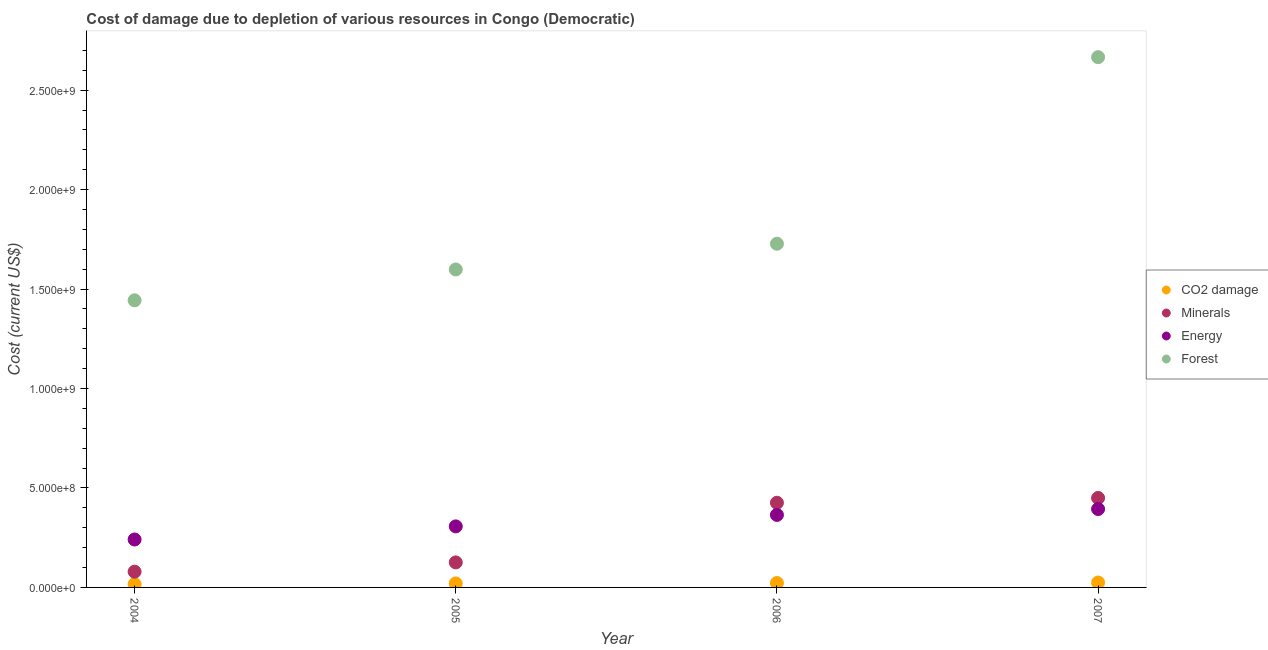Is the number of dotlines equal to the number of legend labels?
Ensure brevity in your answer.  Yes. What is the cost of damage due to depletion of forests in 2006?
Provide a short and direct response. 1.73e+09. Across all years, what is the maximum cost of damage due to depletion of energy?
Ensure brevity in your answer.  3.94e+08. Across all years, what is the minimum cost of damage due to depletion of minerals?
Offer a terse response. 7.91e+07. In which year was the cost of damage due to depletion of forests maximum?
Give a very brief answer. 2007. In which year was the cost of damage due to depletion of minerals minimum?
Give a very brief answer. 2004. What is the total cost of damage due to depletion of energy in the graph?
Offer a terse response. 1.31e+09. What is the difference between the cost of damage due to depletion of energy in 2004 and that in 2005?
Offer a terse response. -6.59e+07. What is the difference between the cost of damage due to depletion of energy in 2006 and the cost of damage due to depletion of minerals in 2004?
Provide a short and direct response. 2.85e+08. What is the average cost of damage due to depletion of coal per year?
Keep it short and to the point. 2.10e+07. In the year 2005, what is the difference between the cost of damage due to depletion of energy and cost of damage due to depletion of coal?
Ensure brevity in your answer.  2.87e+08. What is the ratio of the cost of damage due to depletion of coal in 2005 to that in 2006?
Provide a short and direct response. 0.9. Is the cost of damage due to depletion of coal in 2005 less than that in 2007?
Make the answer very short. Yes. What is the difference between the highest and the second highest cost of damage due to depletion of minerals?
Provide a short and direct response. 2.41e+07. What is the difference between the highest and the lowest cost of damage due to depletion of energy?
Provide a succinct answer. 1.53e+08. In how many years, is the cost of damage due to depletion of minerals greater than the average cost of damage due to depletion of minerals taken over all years?
Make the answer very short. 2. Is it the case that in every year, the sum of the cost of damage due to depletion of coal and cost of damage due to depletion of minerals is greater than the cost of damage due to depletion of energy?
Offer a terse response. No. Is the cost of damage due to depletion of forests strictly less than the cost of damage due to depletion of energy over the years?
Keep it short and to the point. No. How many dotlines are there?
Make the answer very short. 4. How many years are there in the graph?
Make the answer very short. 4. What is the difference between two consecutive major ticks on the Y-axis?
Your answer should be compact. 5.00e+08. Does the graph contain grids?
Offer a terse response. No. Where does the legend appear in the graph?
Keep it short and to the point. Center right. How many legend labels are there?
Your response must be concise. 4. What is the title of the graph?
Keep it short and to the point. Cost of damage due to depletion of various resources in Congo (Democratic) . What is the label or title of the X-axis?
Offer a terse response. Year. What is the label or title of the Y-axis?
Make the answer very short. Cost (current US$). What is the Cost (current US$) in CO2 damage in 2004?
Your answer should be very brief. 1.66e+07. What is the Cost (current US$) in Minerals in 2004?
Keep it short and to the point. 7.91e+07. What is the Cost (current US$) of Energy in 2004?
Your response must be concise. 2.41e+08. What is the Cost (current US$) in Forest in 2004?
Your answer should be very brief. 1.44e+09. What is the Cost (current US$) in CO2 damage in 2005?
Make the answer very short. 2.02e+07. What is the Cost (current US$) of Minerals in 2005?
Offer a very short reply. 1.26e+08. What is the Cost (current US$) of Energy in 2005?
Offer a very short reply. 3.07e+08. What is the Cost (current US$) in Forest in 2005?
Your answer should be very brief. 1.60e+09. What is the Cost (current US$) in CO2 damage in 2006?
Provide a short and direct response. 2.23e+07. What is the Cost (current US$) of Minerals in 2006?
Offer a very short reply. 4.26e+08. What is the Cost (current US$) in Energy in 2006?
Make the answer very short. 3.65e+08. What is the Cost (current US$) of Forest in 2006?
Offer a very short reply. 1.73e+09. What is the Cost (current US$) in CO2 damage in 2007?
Your answer should be very brief. 2.48e+07. What is the Cost (current US$) of Minerals in 2007?
Keep it short and to the point. 4.50e+08. What is the Cost (current US$) of Energy in 2007?
Provide a succinct answer. 3.94e+08. What is the Cost (current US$) of Forest in 2007?
Your response must be concise. 2.67e+09. Across all years, what is the maximum Cost (current US$) in CO2 damage?
Offer a terse response. 2.48e+07. Across all years, what is the maximum Cost (current US$) in Minerals?
Provide a short and direct response. 4.50e+08. Across all years, what is the maximum Cost (current US$) of Energy?
Ensure brevity in your answer.  3.94e+08. Across all years, what is the maximum Cost (current US$) in Forest?
Your response must be concise. 2.67e+09. Across all years, what is the minimum Cost (current US$) of CO2 damage?
Keep it short and to the point. 1.66e+07. Across all years, what is the minimum Cost (current US$) in Minerals?
Ensure brevity in your answer.  7.91e+07. Across all years, what is the minimum Cost (current US$) in Energy?
Offer a very short reply. 2.41e+08. Across all years, what is the minimum Cost (current US$) of Forest?
Offer a terse response. 1.44e+09. What is the total Cost (current US$) in CO2 damage in the graph?
Ensure brevity in your answer.  8.38e+07. What is the total Cost (current US$) in Minerals in the graph?
Your answer should be compact. 1.08e+09. What is the total Cost (current US$) in Energy in the graph?
Your answer should be compact. 1.31e+09. What is the total Cost (current US$) of Forest in the graph?
Ensure brevity in your answer.  7.44e+09. What is the difference between the Cost (current US$) of CO2 damage in 2004 and that in 2005?
Your answer should be very brief. -3.55e+06. What is the difference between the Cost (current US$) of Minerals in 2004 and that in 2005?
Your response must be concise. -4.66e+07. What is the difference between the Cost (current US$) in Energy in 2004 and that in 2005?
Provide a short and direct response. -6.59e+07. What is the difference between the Cost (current US$) of Forest in 2004 and that in 2005?
Provide a short and direct response. -1.55e+08. What is the difference between the Cost (current US$) in CO2 damage in 2004 and that in 2006?
Your response must be concise. -5.69e+06. What is the difference between the Cost (current US$) of Minerals in 2004 and that in 2006?
Give a very brief answer. -3.46e+08. What is the difference between the Cost (current US$) in Energy in 2004 and that in 2006?
Keep it short and to the point. -1.24e+08. What is the difference between the Cost (current US$) of Forest in 2004 and that in 2006?
Keep it short and to the point. -2.84e+08. What is the difference between the Cost (current US$) in CO2 damage in 2004 and that in 2007?
Ensure brevity in your answer.  -8.19e+06. What is the difference between the Cost (current US$) of Minerals in 2004 and that in 2007?
Offer a very short reply. -3.71e+08. What is the difference between the Cost (current US$) in Energy in 2004 and that in 2007?
Ensure brevity in your answer.  -1.53e+08. What is the difference between the Cost (current US$) of Forest in 2004 and that in 2007?
Your answer should be very brief. -1.22e+09. What is the difference between the Cost (current US$) in CO2 damage in 2005 and that in 2006?
Ensure brevity in your answer.  -2.14e+06. What is the difference between the Cost (current US$) of Minerals in 2005 and that in 2006?
Ensure brevity in your answer.  -3.00e+08. What is the difference between the Cost (current US$) of Energy in 2005 and that in 2006?
Provide a succinct answer. -5.77e+07. What is the difference between the Cost (current US$) in Forest in 2005 and that in 2006?
Give a very brief answer. -1.29e+08. What is the difference between the Cost (current US$) of CO2 damage in 2005 and that in 2007?
Offer a very short reply. -4.64e+06. What is the difference between the Cost (current US$) of Minerals in 2005 and that in 2007?
Provide a short and direct response. -3.24e+08. What is the difference between the Cost (current US$) of Energy in 2005 and that in 2007?
Your answer should be compact. -8.72e+07. What is the difference between the Cost (current US$) of Forest in 2005 and that in 2007?
Your answer should be very brief. -1.07e+09. What is the difference between the Cost (current US$) of CO2 damage in 2006 and that in 2007?
Provide a succinct answer. -2.50e+06. What is the difference between the Cost (current US$) of Minerals in 2006 and that in 2007?
Ensure brevity in your answer.  -2.41e+07. What is the difference between the Cost (current US$) of Energy in 2006 and that in 2007?
Give a very brief answer. -2.96e+07. What is the difference between the Cost (current US$) in Forest in 2006 and that in 2007?
Provide a succinct answer. -9.38e+08. What is the difference between the Cost (current US$) of CO2 damage in 2004 and the Cost (current US$) of Minerals in 2005?
Provide a short and direct response. -1.09e+08. What is the difference between the Cost (current US$) of CO2 damage in 2004 and the Cost (current US$) of Energy in 2005?
Ensure brevity in your answer.  -2.90e+08. What is the difference between the Cost (current US$) in CO2 damage in 2004 and the Cost (current US$) in Forest in 2005?
Make the answer very short. -1.58e+09. What is the difference between the Cost (current US$) of Minerals in 2004 and the Cost (current US$) of Energy in 2005?
Offer a terse response. -2.28e+08. What is the difference between the Cost (current US$) of Minerals in 2004 and the Cost (current US$) of Forest in 2005?
Offer a terse response. -1.52e+09. What is the difference between the Cost (current US$) in Energy in 2004 and the Cost (current US$) in Forest in 2005?
Your response must be concise. -1.36e+09. What is the difference between the Cost (current US$) in CO2 damage in 2004 and the Cost (current US$) in Minerals in 2006?
Give a very brief answer. -4.09e+08. What is the difference between the Cost (current US$) of CO2 damage in 2004 and the Cost (current US$) of Energy in 2006?
Your response must be concise. -3.48e+08. What is the difference between the Cost (current US$) in CO2 damage in 2004 and the Cost (current US$) in Forest in 2006?
Your answer should be very brief. -1.71e+09. What is the difference between the Cost (current US$) of Minerals in 2004 and the Cost (current US$) of Energy in 2006?
Offer a very short reply. -2.85e+08. What is the difference between the Cost (current US$) in Minerals in 2004 and the Cost (current US$) in Forest in 2006?
Your answer should be compact. -1.65e+09. What is the difference between the Cost (current US$) in Energy in 2004 and the Cost (current US$) in Forest in 2006?
Provide a short and direct response. -1.49e+09. What is the difference between the Cost (current US$) in CO2 damage in 2004 and the Cost (current US$) in Minerals in 2007?
Keep it short and to the point. -4.33e+08. What is the difference between the Cost (current US$) of CO2 damage in 2004 and the Cost (current US$) of Energy in 2007?
Keep it short and to the point. -3.78e+08. What is the difference between the Cost (current US$) of CO2 damage in 2004 and the Cost (current US$) of Forest in 2007?
Ensure brevity in your answer.  -2.65e+09. What is the difference between the Cost (current US$) of Minerals in 2004 and the Cost (current US$) of Energy in 2007?
Give a very brief answer. -3.15e+08. What is the difference between the Cost (current US$) of Minerals in 2004 and the Cost (current US$) of Forest in 2007?
Make the answer very short. -2.59e+09. What is the difference between the Cost (current US$) of Energy in 2004 and the Cost (current US$) of Forest in 2007?
Provide a succinct answer. -2.42e+09. What is the difference between the Cost (current US$) of CO2 damage in 2005 and the Cost (current US$) of Minerals in 2006?
Provide a succinct answer. -4.05e+08. What is the difference between the Cost (current US$) of CO2 damage in 2005 and the Cost (current US$) of Energy in 2006?
Your answer should be very brief. -3.44e+08. What is the difference between the Cost (current US$) of CO2 damage in 2005 and the Cost (current US$) of Forest in 2006?
Your answer should be compact. -1.71e+09. What is the difference between the Cost (current US$) in Minerals in 2005 and the Cost (current US$) in Energy in 2006?
Provide a short and direct response. -2.39e+08. What is the difference between the Cost (current US$) in Minerals in 2005 and the Cost (current US$) in Forest in 2006?
Give a very brief answer. -1.60e+09. What is the difference between the Cost (current US$) of Energy in 2005 and the Cost (current US$) of Forest in 2006?
Give a very brief answer. -1.42e+09. What is the difference between the Cost (current US$) in CO2 damage in 2005 and the Cost (current US$) in Minerals in 2007?
Provide a succinct answer. -4.30e+08. What is the difference between the Cost (current US$) in CO2 damage in 2005 and the Cost (current US$) in Energy in 2007?
Offer a very short reply. -3.74e+08. What is the difference between the Cost (current US$) in CO2 damage in 2005 and the Cost (current US$) in Forest in 2007?
Offer a very short reply. -2.65e+09. What is the difference between the Cost (current US$) of Minerals in 2005 and the Cost (current US$) of Energy in 2007?
Offer a terse response. -2.68e+08. What is the difference between the Cost (current US$) in Minerals in 2005 and the Cost (current US$) in Forest in 2007?
Provide a succinct answer. -2.54e+09. What is the difference between the Cost (current US$) in Energy in 2005 and the Cost (current US$) in Forest in 2007?
Your answer should be compact. -2.36e+09. What is the difference between the Cost (current US$) of CO2 damage in 2006 and the Cost (current US$) of Minerals in 2007?
Ensure brevity in your answer.  -4.27e+08. What is the difference between the Cost (current US$) in CO2 damage in 2006 and the Cost (current US$) in Energy in 2007?
Your response must be concise. -3.72e+08. What is the difference between the Cost (current US$) in CO2 damage in 2006 and the Cost (current US$) in Forest in 2007?
Your answer should be compact. -2.64e+09. What is the difference between the Cost (current US$) of Minerals in 2006 and the Cost (current US$) of Energy in 2007?
Ensure brevity in your answer.  3.15e+07. What is the difference between the Cost (current US$) in Minerals in 2006 and the Cost (current US$) in Forest in 2007?
Make the answer very short. -2.24e+09. What is the difference between the Cost (current US$) in Energy in 2006 and the Cost (current US$) in Forest in 2007?
Ensure brevity in your answer.  -2.30e+09. What is the average Cost (current US$) in CO2 damage per year?
Offer a terse response. 2.10e+07. What is the average Cost (current US$) of Minerals per year?
Your answer should be very brief. 2.70e+08. What is the average Cost (current US$) of Energy per year?
Make the answer very short. 3.27e+08. What is the average Cost (current US$) in Forest per year?
Offer a terse response. 1.86e+09. In the year 2004, what is the difference between the Cost (current US$) of CO2 damage and Cost (current US$) of Minerals?
Give a very brief answer. -6.25e+07. In the year 2004, what is the difference between the Cost (current US$) in CO2 damage and Cost (current US$) in Energy?
Offer a terse response. -2.24e+08. In the year 2004, what is the difference between the Cost (current US$) of CO2 damage and Cost (current US$) of Forest?
Give a very brief answer. -1.43e+09. In the year 2004, what is the difference between the Cost (current US$) of Minerals and Cost (current US$) of Energy?
Your answer should be very brief. -1.62e+08. In the year 2004, what is the difference between the Cost (current US$) of Minerals and Cost (current US$) of Forest?
Give a very brief answer. -1.36e+09. In the year 2004, what is the difference between the Cost (current US$) in Energy and Cost (current US$) in Forest?
Ensure brevity in your answer.  -1.20e+09. In the year 2005, what is the difference between the Cost (current US$) in CO2 damage and Cost (current US$) in Minerals?
Your answer should be compact. -1.06e+08. In the year 2005, what is the difference between the Cost (current US$) in CO2 damage and Cost (current US$) in Energy?
Provide a short and direct response. -2.87e+08. In the year 2005, what is the difference between the Cost (current US$) of CO2 damage and Cost (current US$) of Forest?
Provide a short and direct response. -1.58e+09. In the year 2005, what is the difference between the Cost (current US$) in Minerals and Cost (current US$) in Energy?
Your response must be concise. -1.81e+08. In the year 2005, what is the difference between the Cost (current US$) of Minerals and Cost (current US$) of Forest?
Your response must be concise. -1.47e+09. In the year 2005, what is the difference between the Cost (current US$) in Energy and Cost (current US$) in Forest?
Keep it short and to the point. -1.29e+09. In the year 2006, what is the difference between the Cost (current US$) of CO2 damage and Cost (current US$) of Minerals?
Offer a very short reply. -4.03e+08. In the year 2006, what is the difference between the Cost (current US$) in CO2 damage and Cost (current US$) in Energy?
Your answer should be very brief. -3.42e+08. In the year 2006, what is the difference between the Cost (current US$) in CO2 damage and Cost (current US$) in Forest?
Offer a terse response. -1.71e+09. In the year 2006, what is the difference between the Cost (current US$) of Minerals and Cost (current US$) of Energy?
Keep it short and to the point. 6.11e+07. In the year 2006, what is the difference between the Cost (current US$) of Minerals and Cost (current US$) of Forest?
Your answer should be very brief. -1.30e+09. In the year 2006, what is the difference between the Cost (current US$) in Energy and Cost (current US$) in Forest?
Offer a very short reply. -1.36e+09. In the year 2007, what is the difference between the Cost (current US$) of CO2 damage and Cost (current US$) of Minerals?
Make the answer very short. -4.25e+08. In the year 2007, what is the difference between the Cost (current US$) in CO2 damage and Cost (current US$) in Energy?
Keep it short and to the point. -3.69e+08. In the year 2007, what is the difference between the Cost (current US$) of CO2 damage and Cost (current US$) of Forest?
Ensure brevity in your answer.  -2.64e+09. In the year 2007, what is the difference between the Cost (current US$) in Minerals and Cost (current US$) in Energy?
Keep it short and to the point. 5.56e+07. In the year 2007, what is the difference between the Cost (current US$) of Minerals and Cost (current US$) of Forest?
Your response must be concise. -2.22e+09. In the year 2007, what is the difference between the Cost (current US$) of Energy and Cost (current US$) of Forest?
Provide a succinct answer. -2.27e+09. What is the ratio of the Cost (current US$) in CO2 damage in 2004 to that in 2005?
Provide a succinct answer. 0.82. What is the ratio of the Cost (current US$) in Minerals in 2004 to that in 2005?
Make the answer very short. 0.63. What is the ratio of the Cost (current US$) of Energy in 2004 to that in 2005?
Offer a terse response. 0.79. What is the ratio of the Cost (current US$) in Forest in 2004 to that in 2005?
Your answer should be very brief. 0.9. What is the ratio of the Cost (current US$) in CO2 damage in 2004 to that in 2006?
Offer a very short reply. 0.74. What is the ratio of the Cost (current US$) in Minerals in 2004 to that in 2006?
Provide a succinct answer. 0.19. What is the ratio of the Cost (current US$) of Energy in 2004 to that in 2006?
Your answer should be very brief. 0.66. What is the ratio of the Cost (current US$) of Forest in 2004 to that in 2006?
Offer a very short reply. 0.84. What is the ratio of the Cost (current US$) in CO2 damage in 2004 to that in 2007?
Offer a terse response. 0.67. What is the ratio of the Cost (current US$) of Minerals in 2004 to that in 2007?
Keep it short and to the point. 0.18. What is the ratio of the Cost (current US$) in Energy in 2004 to that in 2007?
Provide a short and direct response. 0.61. What is the ratio of the Cost (current US$) in Forest in 2004 to that in 2007?
Your answer should be compact. 0.54. What is the ratio of the Cost (current US$) in CO2 damage in 2005 to that in 2006?
Provide a succinct answer. 0.9. What is the ratio of the Cost (current US$) of Minerals in 2005 to that in 2006?
Offer a terse response. 0.3. What is the ratio of the Cost (current US$) of Energy in 2005 to that in 2006?
Offer a very short reply. 0.84. What is the ratio of the Cost (current US$) in Forest in 2005 to that in 2006?
Make the answer very short. 0.93. What is the ratio of the Cost (current US$) in CO2 damage in 2005 to that in 2007?
Give a very brief answer. 0.81. What is the ratio of the Cost (current US$) of Minerals in 2005 to that in 2007?
Provide a short and direct response. 0.28. What is the ratio of the Cost (current US$) of Energy in 2005 to that in 2007?
Make the answer very short. 0.78. What is the ratio of the Cost (current US$) of Forest in 2005 to that in 2007?
Provide a short and direct response. 0.6. What is the ratio of the Cost (current US$) of CO2 damage in 2006 to that in 2007?
Provide a short and direct response. 0.9. What is the ratio of the Cost (current US$) of Minerals in 2006 to that in 2007?
Ensure brevity in your answer.  0.95. What is the ratio of the Cost (current US$) of Energy in 2006 to that in 2007?
Give a very brief answer. 0.93. What is the ratio of the Cost (current US$) in Forest in 2006 to that in 2007?
Ensure brevity in your answer.  0.65. What is the difference between the highest and the second highest Cost (current US$) in CO2 damage?
Offer a very short reply. 2.50e+06. What is the difference between the highest and the second highest Cost (current US$) of Minerals?
Offer a very short reply. 2.41e+07. What is the difference between the highest and the second highest Cost (current US$) of Energy?
Provide a short and direct response. 2.96e+07. What is the difference between the highest and the second highest Cost (current US$) of Forest?
Ensure brevity in your answer.  9.38e+08. What is the difference between the highest and the lowest Cost (current US$) of CO2 damage?
Give a very brief answer. 8.19e+06. What is the difference between the highest and the lowest Cost (current US$) of Minerals?
Provide a succinct answer. 3.71e+08. What is the difference between the highest and the lowest Cost (current US$) in Energy?
Offer a very short reply. 1.53e+08. What is the difference between the highest and the lowest Cost (current US$) of Forest?
Offer a very short reply. 1.22e+09. 